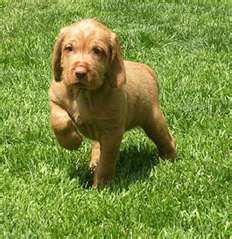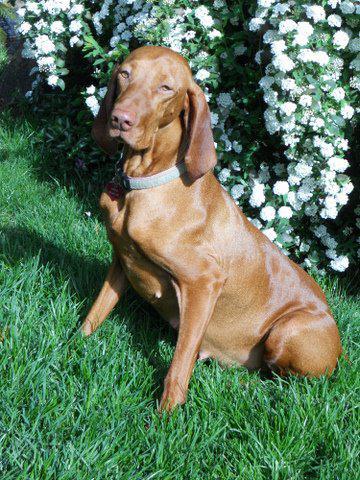The first image is the image on the left, the second image is the image on the right. Given the left and right images, does the statement "The dog in the image on the left is standing in the grass." hold true? Answer yes or no. Yes. The first image is the image on the left, the second image is the image on the right. For the images shown, is this caption "Each image contains exactly one red-orange dog, one image shows a puppy headed across the grass with a front paw raised, and the other shows a dog wearing a bluish collar." true? Answer yes or no. Yes. 